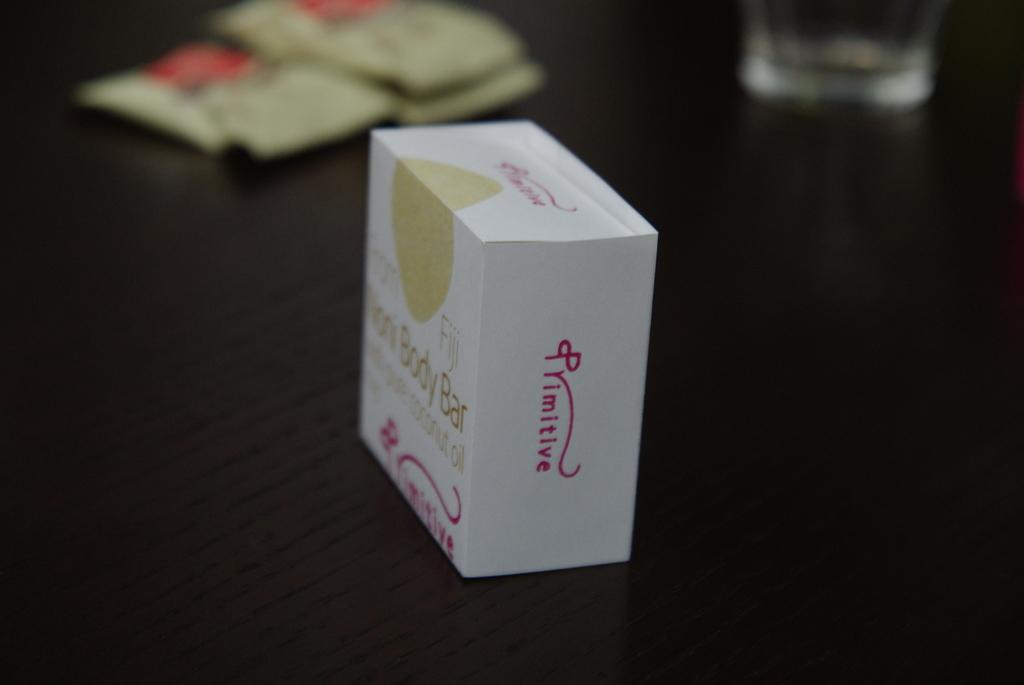<image>
Summarize the visual content of the image. A bar of coconut oil soap with body bar on it 